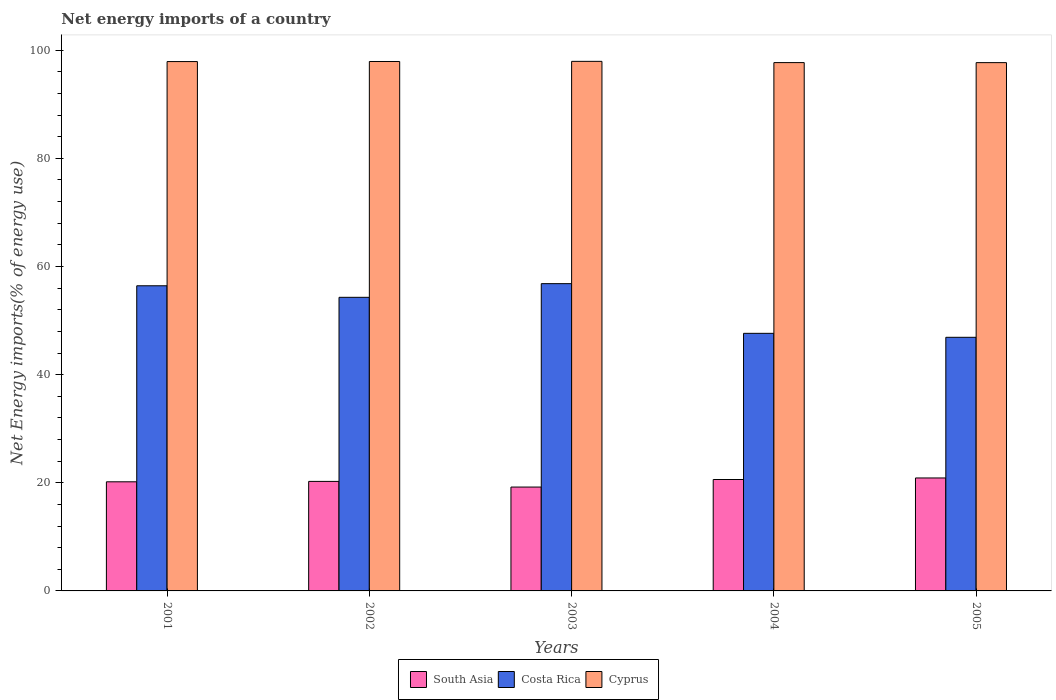How many different coloured bars are there?
Provide a short and direct response. 3. Are the number of bars on each tick of the X-axis equal?
Your response must be concise. Yes. What is the net energy imports in Costa Rica in 2005?
Your answer should be compact. 46.9. Across all years, what is the maximum net energy imports in Costa Rica?
Offer a terse response. 56.83. Across all years, what is the minimum net energy imports in Cyprus?
Your answer should be compact. 97.7. In which year was the net energy imports in South Asia maximum?
Your response must be concise. 2005. What is the total net energy imports in South Asia in the graph?
Provide a short and direct response. 101.14. What is the difference between the net energy imports in Cyprus in 2002 and that in 2003?
Offer a terse response. -0.02. What is the difference between the net energy imports in South Asia in 2001 and the net energy imports in Cyprus in 2004?
Give a very brief answer. -77.53. What is the average net energy imports in Costa Rica per year?
Ensure brevity in your answer.  52.42. In the year 2004, what is the difference between the net energy imports in South Asia and net energy imports in Cyprus?
Offer a very short reply. -77.1. In how many years, is the net energy imports in Cyprus greater than 84 %?
Keep it short and to the point. 5. What is the ratio of the net energy imports in South Asia in 2002 to that in 2004?
Keep it short and to the point. 0.98. Is the net energy imports in Cyprus in 2002 less than that in 2005?
Ensure brevity in your answer.  No. Is the difference between the net energy imports in South Asia in 2002 and 2003 greater than the difference between the net energy imports in Cyprus in 2002 and 2003?
Keep it short and to the point. Yes. What is the difference between the highest and the second highest net energy imports in South Asia?
Offer a very short reply. 0.29. What is the difference between the highest and the lowest net energy imports in Cyprus?
Offer a terse response. 0.24. In how many years, is the net energy imports in South Asia greater than the average net energy imports in South Asia taken over all years?
Offer a terse response. 3. Is the sum of the net energy imports in South Asia in 2001 and 2004 greater than the maximum net energy imports in Costa Rica across all years?
Offer a terse response. No. What does the 3rd bar from the left in 2004 represents?
Your answer should be very brief. Cyprus. How many bars are there?
Keep it short and to the point. 15. How many years are there in the graph?
Keep it short and to the point. 5. Are the values on the major ticks of Y-axis written in scientific E-notation?
Ensure brevity in your answer.  No. Where does the legend appear in the graph?
Offer a very short reply. Bottom center. How many legend labels are there?
Give a very brief answer. 3. What is the title of the graph?
Make the answer very short. Net energy imports of a country. What is the label or title of the X-axis?
Provide a succinct answer. Years. What is the label or title of the Y-axis?
Offer a very short reply. Net Energy imports(% of energy use). What is the Net Energy imports(% of energy use) of South Asia in 2001?
Give a very brief answer. 20.18. What is the Net Energy imports(% of energy use) of Costa Rica in 2001?
Provide a succinct answer. 56.43. What is the Net Energy imports(% of energy use) in Cyprus in 2001?
Keep it short and to the point. 97.9. What is the Net Energy imports(% of energy use) of South Asia in 2002?
Provide a succinct answer. 20.25. What is the Net Energy imports(% of energy use) of Costa Rica in 2002?
Give a very brief answer. 54.3. What is the Net Energy imports(% of energy use) of Cyprus in 2002?
Your answer should be very brief. 97.91. What is the Net Energy imports(% of energy use) of South Asia in 2003?
Give a very brief answer. 19.21. What is the Net Energy imports(% of energy use) in Costa Rica in 2003?
Keep it short and to the point. 56.83. What is the Net Energy imports(% of energy use) in Cyprus in 2003?
Your response must be concise. 97.94. What is the Net Energy imports(% of energy use) of South Asia in 2004?
Your response must be concise. 20.6. What is the Net Energy imports(% of energy use) of Costa Rica in 2004?
Keep it short and to the point. 47.64. What is the Net Energy imports(% of energy use) of Cyprus in 2004?
Give a very brief answer. 97.71. What is the Net Energy imports(% of energy use) in South Asia in 2005?
Ensure brevity in your answer.  20.89. What is the Net Energy imports(% of energy use) in Costa Rica in 2005?
Give a very brief answer. 46.9. What is the Net Energy imports(% of energy use) of Cyprus in 2005?
Provide a short and direct response. 97.7. Across all years, what is the maximum Net Energy imports(% of energy use) in South Asia?
Give a very brief answer. 20.89. Across all years, what is the maximum Net Energy imports(% of energy use) in Costa Rica?
Your answer should be compact. 56.83. Across all years, what is the maximum Net Energy imports(% of energy use) in Cyprus?
Your answer should be very brief. 97.94. Across all years, what is the minimum Net Energy imports(% of energy use) in South Asia?
Your response must be concise. 19.21. Across all years, what is the minimum Net Energy imports(% of energy use) of Costa Rica?
Keep it short and to the point. 46.9. Across all years, what is the minimum Net Energy imports(% of energy use) of Cyprus?
Provide a succinct answer. 97.7. What is the total Net Energy imports(% of energy use) in South Asia in the graph?
Provide a succinct answer. 101.14. What is the total Net Energy imports(% of energy use) of Costa Rica in the graph?
Give a very brief answer. 262.1. What is the total Net Energy imports(% of energy use) of Cyprus in the graph?
Your answer should be compact. 489.16. What is the difference between the Net Energy imports(% of energy use) of South Asia in 2001 and that in 2002?
Provide a short and direct response. -0.07. What is the difference between the Net Energy imports(% of energy use) in Costa Rica in 2001 and that in 2002?
Provide a short and direct response. 2.13. What is the difference between the Net Energy imports(% of energy use) of Cyprus in 2001 and that in 2002?
Make the answer very short. -0.02. What is the difference between the Net Energy imports(% of energy use) of South Asia in 2001 and that in 2003?
Your answer should be compact. 0.97. What is the difference between the Net Energy imports(% of energy use) of Costa Rica in 2001 and that in 2003?
Your response must be concise. -0.39. What is the difference between the Net Energy imports(% of energy use) in Cyprus in 2001 and that in 2003?
Offer a very short reply. -0.04. What is the difference between the Net Energy imports(% of energy use) in South Asia in 2001 and that in 2004?
Your response must be concise. -0.42. What is the difference between the Net Energy imports(% of energy use) of Costa Rica in 2001 and that in 2004?
Ensure brevity in your answer.  8.8. What is the difference between the Net Energy imports(% of energy use) in Cyprus in 2001 and that in 2004?
Keep it short and to the point. 0.19. What is the difference between the Net Energy imports(% of energy use) in South Asia in 2001 and that in 2005?
Keep it short and to the point. -0.71. What is the difference between the Net Energy imports(% of energy use) of Costa Rica in 2001 and that in 2005?
Your answer should be compact. 9.53. What is the difference between the Net Energy imports(% of energy use) of Cyprus in 2001 and that in 2005?
Your answer should be very brief. 0.2. What is the difference between the Net Energy imports(% of energy use) in South Asia in 2002 and that in 2003?
Your answer should be very brief. 1.05. What is the difference between the Net Energy imports(% of energy use) in Costa Rica in 2002 and that in 2003?
Ensure brevity in your answer.  -2.53. What is the difference between the Net Energy imports(% of energy use) in Cyprus in 2002 and that in 2003?
Your answer should be compact. -0.02. What is the difference between the Net Energy imports(% of energy use) of South Asia in 2002 and that in 2004?
Offer a terse response. -0.35. What is the difference between the Net Energy imports(% of energy use) of Costa Rica in 2002 and that in 2004?
Keep it short and to the point. 6.66. What is the difference between the Net Energy imports(% of energy use) of Cyprus in 2002 and that in 2004?
Offer a terse response. 0.21. What is the difference between the Net Energy imports(% of energy use) of South Asia in 2002 and that in 2005?
Your answer should be compact. -0.64. What is the difference between the Net Energy imports(% of energy use) in Costa Rica in 2002 and that in 2005?
Offer a terse response. 7.4. What is the difference between the Net Energy imports(% of energy use) of Cyprus in 2002 and that in 2005?
Offer a terse response. 0.21. What is the difference between the Net Energy imports(% of energy use) in South Asia in 2003 and that in 2004?
Make the answer very short. -1.4. What is the difference between the Net Energy imports(% of energy use) of Costa Rica in 2003 and that in 2004?
Keep it short and to the point. 9.19. What is the difference between the Net Energy imports(% of energy use) in Cyprus in 2003 and that in 2004?
Make the answer very short. 0.23. What is the difference between the Net Energy imports(% of energy use) in South Asia in 2003 and that in 2005?
Provide a short and direct response. -1.68. What is the difference between the Net Energy imports(% of energy use) of Costa Rica in 2003 and that in 2005?
Make the answer very short. 9.92. What is the difference between the Net Energy imports(% of energy use) of Cyprus in 2003 and that in 2005?
Give a very brief answer. 0.24. What is the difference between the Net Energy imports(% of energy use) of South Asia in 2004 and that in 2005?
Ensure brevity in your answer.  -0.29. What is the difference between the Net Energy imports(% of energy use) of Costa Rica in 2004 and that in 2005?
Provide a short and direct response. 0.74. What is the difference between the Net Energy imports(% of energy use) of Cyprus in 2004 and that in 2005?
Provide a short and direct response. 0.01. What is the difference between the Net Energy imports(% of energy use) of South Asia in 2001 and the Net Energy imports(% of energy use) of Costa Rica in 2002?
Your response must be concise. -34.12. What is the difference between the Net Energy imports(% of energy use) of South Asia in 2001 and the Net Energy imports(% of energy use) of Cyprus in 2002?
Give a very brief answer. -77.73. What is the difference between the Net Energy imports(% of energy use) of Costa Rica in 2001 and the Net Energy imports(% of energy use) of Cyprus in 2002?
Keep it short and to the point. -41.48. What is the difference between the Net Energy imports(% of energy use) in South Asia in 2001 and the Net Energy imports(% of energy use) in Costa Rica in 2003?
Make the answer very short. -36.64. What is the difference between the Net Energy imports(% of energy use) of South Asia in 2001 and the Net Energy imports(% of energy use) of Cyprus in 2003?
Keep it short and to the point. -77.76. What is the difference between the Net Energy imports(% of energy use) in Costa Rica in 2001 and the Net Energy imports(% of energy use) in Cyprus in 2003?
Offer a very short reply. -41.5. What is the difference between the Net Energy imports(% of energy use) in South Asia in 2001 and the Net Energy imports(% of energy use) in Costa Rica in 2004?
Ensure brevity in your answer.  -27.46. What is the difference between the Net Energy imports(% of energy use) of South Asia in 2001 and the Net Energy imports(% of energy use) of Cyprus in 2004?
Your response must be concise. -77.53. What is the difference between the Net Energy imports(% of energy use) in Costa Rica in 2001 and the Net Energy imports(% of energy use) in Cyprus in 2004?
Make the answer very short. -41.27. What is the difference between the Net Energy imports(% of energy use) in South Asia in 2001 and the Net Energy imports(% of energy use) in Costa Rica in 2005?
Provide a short and direct response. -26.72. What is the difference between the Net Energy imports(% of energy use) of South Asia in 2001 and the Net Energy imports(% of energy use) of Cyprus in 2005?
Offer a terse response. -77.52. What is the difference between the Net Energy imports(% of energy use) of Costa Rica in 2001 and the Net Energy imports(% of energy use) of Cyprus in 2005?
Your answer should be compact. -41.27. What is the difference between the Net Energy imports(% of energy use) in South Asia in 2002 and the Net Energy imports(% of energy use) in Costa Rica in 2003?
Make the answer very short. -36.57. What is the difference between the Net Energy imports(% of energy use) of South Asia in 2002 and the Net Energy imports(% of energy use) of Cyprus in 2003?
Your answer should be very brief. -77.68. What is the difference between the Net Energy imports(% of energy use) of Costa Rica in 2002 and the Net Energy imports(% of energy use) of Cyprus in 2003?
Your answer should be very brief. -43.64. What is the difference between the Net Energy imports(% of energy use) of South Asia in 2002 and the Net Energy imports(% of energy use) of Costa Rica in 2004?
Your answer should be compact. -27.38. What is the difference between the Net Energy imports(% of energy use) in South Asia in 2002 and the Net Energy imports(% of energy use) in Cyprus in 2004?
Your answer should be compact. -77.45. What is the difference between the Net Energy imports(% of energy use) in Costa Rica in 2002 and the Net Energy imports(% of energy use) in Cyprus in 2004?
Make the answer very short. -43.41. What is the difference between the Net Energy imports(% of energy use) in South Asia in 2002 and the Net Energy imports(% of energy use) in Costa Rica in 2005?
Provide a short and direct response. -26.65. What is the difference between the Net Energy imports(% of energy use) of South Asia in 2002 and the Net Energy imports(% of energy use) of Cyprus in 2005?
Offer a very short reply. -77.45. What is the difference between the Net Energy imports(% of energy use) in Costa Rica in 2002 and the Net Energy imports(% of energy use) in Cyprus in 2005?
Your response must be concise. -43.4. What is the difference between the Net Energy imports(% of energy use) in South Asia in 2003 and the Net Energy imports(% of energy use) in Costa Rica in 2004?
Provide a short and direct response. -28.43. What is the difference between the Net Energy imports(% of energy use) of South Asia in 2003 and the Net Energy imports(% of energy use) of Cyprus in 2004?
Your answer should be compact. -78.5. What is the difference between the Net Energy imports(% of energy use) of Costa Rica in 2003 and the Net Energy imports(% of energy use) of Cyprus in 2004?
Offer a terse response. -40.88. What is the difference between the Net Energy imports(% of energy use) in South Asia in 2003 and the Net Energy imports(% of energy use) in Costa Rica in 2005?
Your answer should be very brief. -27.69. What is the difference between the Net Energy imports(% of energy use) of South Asia in 2003 and the Net Energy imports(% of energy use) of Cyprus in 2005?
Give a very brief answer. -78.49. What is the difference between the Net Energy imports(% of energy use) in Costa Rica in 2003 and the Net Energy imports(% of energy use) in Cyprus in 2005?
Offer a terse response. -40.88. What is the difference between the Net Energy imports(% of energy use) in South Asia in 2004 and the Net Energy imports(% of energy use) in Costa Rica in 2005?
Ensure brevity in your answer.  -26.3. What is the difference between the Net Energy imports(% of energy use) of South Asia in 2004 and the Net Energy imports(% of energy use) of Cyprus in 2005?
Provide a short and direct response. -77.1. What is the difference between the Net Energy imports(% of energy use) of Costa Rica in 2004 and the Net Energy imports(% of energy use) of Cyprus in 2005?
Make the answer very short. -50.06. What is the average Net Energy imports(% of energy use) in South Asia per year?
Offer a terse response. 20.23. What is the average Net Energy imports(% of energy use) in Costa Rica per year?
Give a very brief answer. 52.42. What is the average Net Energy imports(% of energy use) in Cyprus per year?
Your response must be concise. 97.83. In the year 2001, what is the difference between the Net Energy imports(% of energy use) in South Asia and Net Energy imports(% of energy use) in Costa Rica?
Offer a very short reply. -36.25. In the year 2001, what is the difference between the Net Energy imports(% of energy use) in South Asia and Net Energy imports(% of energy use) in Cyprus?
Your answer should be very brief. -77.72. In the year 2001, what is the difference between the Net Energy imports(% of energy use) of Costa Rica and Net Energy imports(% of energy use) of Cyprus?
Provide a succinct answer. -41.46. In the year 2002, what is the difference between the Net Energy imports(% of energy use) of South Asia and Net Energy imports(% of energy use) of Costa Rica?
Your answer should be very brief. -34.04. In the year 2002, what is the difference between the Net Energy imports(% of energy use) in South Asia and Net Energy imports(% of energy use) in Cyprus?
Make the answer very short. -77.66. In the year 2002, what is the difference between the Net Energy imports(% of energy use) in Costa Rica and Net Energy imports(% of energy use) in Cyprus?
Make the answer very short. -43.62. In the year 2003, what is the difference between the Net Energy imports(% of energy use) of South Asia and Net Energy imports(% of energy use) of Costa Rica?
Provide a short and direct response. -37.62. In the year 2003, what is the difference between the Net Energy imports(% of energy use) in South Asia and Net Energy imports(% of energy use) in Cyprus?
Offer a very short reply. -78.73. In the year 2003, what is the difference between the Net Energy imports(% of energy use) of Costa Rica and Net Energy imports(% of energy use) of Cyprus?
Your answer should be very brief. -41.11. In the year 2004, what is the difference between the Net Energy imports(% of energy use) of South Asia and Net Energy imports(% of energy use) of Costa Rica?
Give a very brief answer. -27.03. In the year 2004, what is the difference between the Net Energy imports(% of energy use) of South Asia and Net Energy imports(% of energy use) of Cyprus?
Your answer should be very brief. -77.1. In the year 2004, what is the difference between the Net Energy imports(% of energy use) in Costa Rica and Net Energy imports(% of energy use) in Cyprus?
Offer a terse response. -50.07. In the year 2005, what is the difference between the Net Energy imports(% of energy use) of South Asia and Net Energy imports(% of energy use) of Costa Rica?
Provide a succinct answer. -26.01. In the year 2005, what is the difference between the Net Energy imports(% of energy use) of South Asia and Net Energy imports(% of energy use) of Cyprus?
Ensure brevity in your answer.  -76.81. In the year 2005, what is the difference between the Net Energy imports(% of energy use) in Costa Rica and Net Energy imports(% of energy use) in Cyprus?
Your answer should be very brief. -50.8. What is the ratio of the Net Energy imports(% of energy use) of Costa Rica in 2001 to that in 2002?
Offer a terse response. 1.04. What is the ratio of the Net Energy imports(% of energy use) in Cyprus in 2001 to that in 2002?
Make the answer very short. 1. What is the ratio of the Net Energy imports(% of energy use) in South Asia in 2001 to that in 2003?
Keep it short and to the point. 1.05. What is the ratio of the Net Energy imports(% of energy use) in Costa Rica in 2001 to that in 2003?
Keep it short and to the point. 0.99. What is the ratio of the Net Energy imports(% of energy use) of South Asia in 2001 to that in 2004?
Give a very brief answer. 0.98. What is the ratio of the Net Energy imports(% of energy use) of Costa Rica in 2001 to that in 2004?
Your response must be concise. 1.18. What is the ratio of the Net Energy imports(% of energy use) of South Asia in 2001 to that in 2005?
Keep it short and to the point. 0.97. What is the ratio of the Net Energy imports(% of energy use) of Costa Rica in 2001 to that in 2005?
Your response must be concise. 1.2. What is the ratio of the Net Energy imports(% of energy use) in South Asia in 2002 to that in 2003?
Provide a short and direct response. 1.05. What is the ratio of the Net Energy imports(% of energy use) of Costa Rica in 2002 to that in 2003?
Your answer should be compact. 0.96. What is the ratio of the Net Energy imports(% of energy use) in Cyprus in 2002 to that in 2003?
Ensure brevity in your answer.  1. What is the ratio of the Net Energy imports(% of energy use) in South Asia in 2002 to that in 2004?
Offer a terse response. 0.98. What is the ratio of the Net Energy imports(% of energy use) of Costa Rica in 2002 to that in 2004?
Give a very brief answer. 1.14. What is the ratio of the Net Energy imports(% of energy use) of Cyprus in 2002 to that in 2004?
Offer a terse response. 1. What is the ratio of the Net Energy imports(% of energy use) of South Asia in 2002 to that in 2005?
Offer a very short reply. 0.97. What is the ratio of the Net Energy imports(% of energy use) of Costa Rica in 2002 to that in 2005?
Offer a very short reply. 1.16. What is the ratio of the Net Energy imports(% of energy use) of South Asia in 2003 to that in 2004?
Ensure brevity in your answer.  0.93. What is the ratio of the Net Energy imports(% of energy use) in Costa Rica in 2003 to that in 2004?
Your answer should be very brief. 1.19. What is the ratio of the Net Energy imports(% of energy use) in South Asia in 2003 to that in 2005?
Provide a succinct answer. 0.92. What is the ratio of the Net Energy imports(% of energy use) of Costa Rica in 2003 to that in 2005?
Ensure brevity in your answer.  1.21. What is the ratio of the Net Energy imports(% of energy use) in South Asia in 2004 to that in 2005?
Make the answer very short. 0.99. What is the ratio of the Net Energy imports(% of energy use) in Costa Rica in 2004 to that in 2005?
Your answer should be very brief. 1.02. What is the difference between the highest and the second highest Net Energy imports(% of energy use) of South Asia?
Your response must be concise. 0.29. What is the difference between the highest and the second highest Net Energy imports(% of energy use) of Costa Rica?
Provide a short and direct response. 0.39. What is the difference between the highest and the second highest Net Energy imports(% of energy use) in Cyprus?
Provide a succinct answer. 0.02. What is the difference between the highest and the lowest Net Energy imports(% of energy use) of South Asia?
Make the answer very short. 1.68. What is the difference between the highest and the lowest Net Energy imports(% of energy use) of Costa Rica?
Your answer should be very brief. 9.92. What is the difference between the highest and the lowest Net Energy imports(% of energy use) of Cyprus?
Your response must be concise. 0.24. 